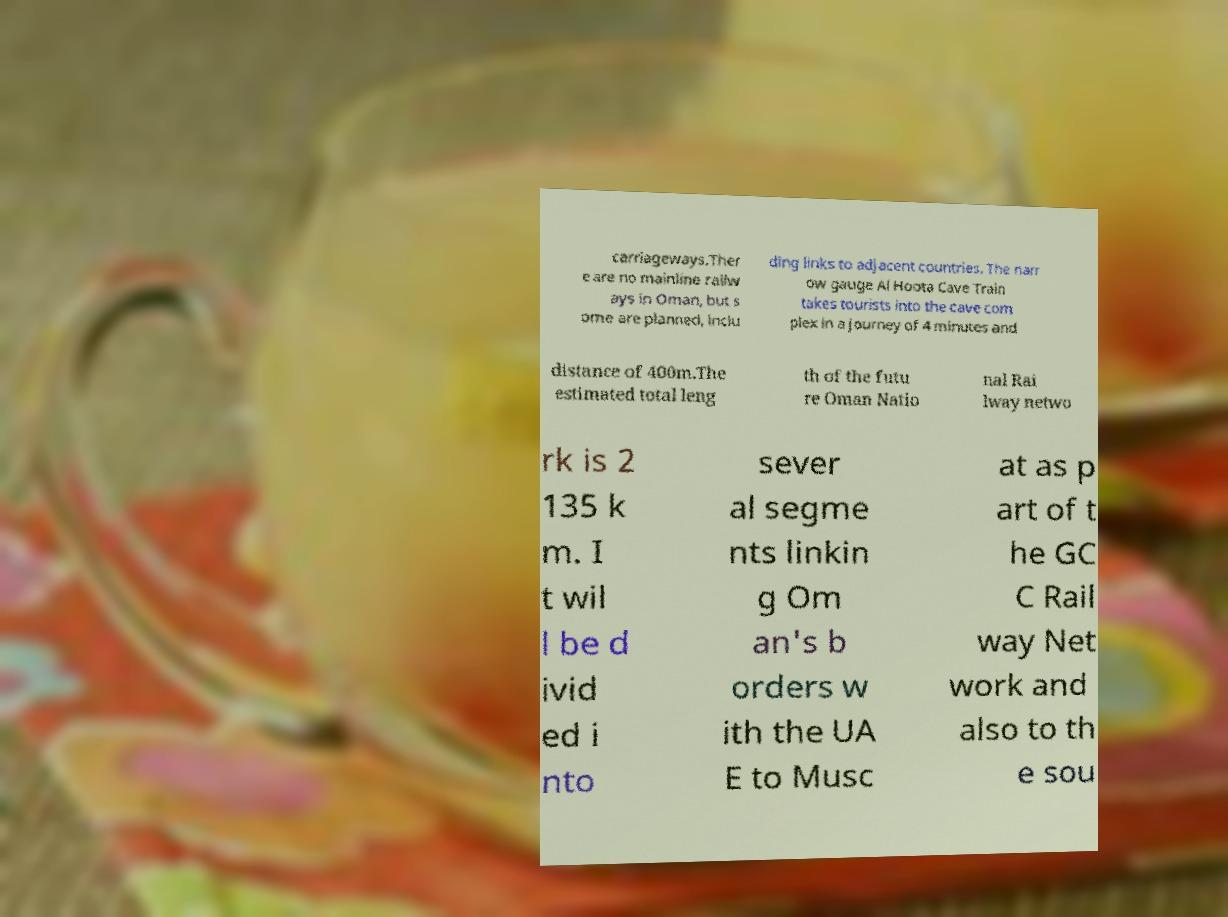Please identify and transcribe the text found in this image. carriageways.Ther e are no mainline railw ays in Oman, but s ome are planned, inclu ding links to adjacent countries. The narr ow gauge Al Hoota Cave Train takes tourists into the cave com plex in a journey of 4 minutes and distance of 400m.The estimated total leng th of the futu re Oman Natio nal Rai lway netwo rk is 2 135 k m. I t wil l be d ivid ed i nto sever al segme nts linkin g Om an's b orders w ith the UA E to Musc at as p art of t he GC C Rail way Net work and also to th e sou 